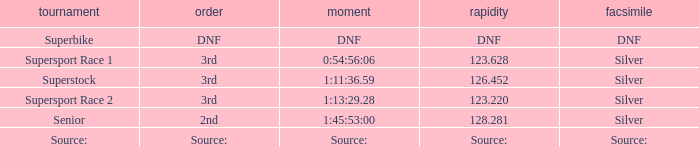Which race has a replica of DNF? Superbike. 